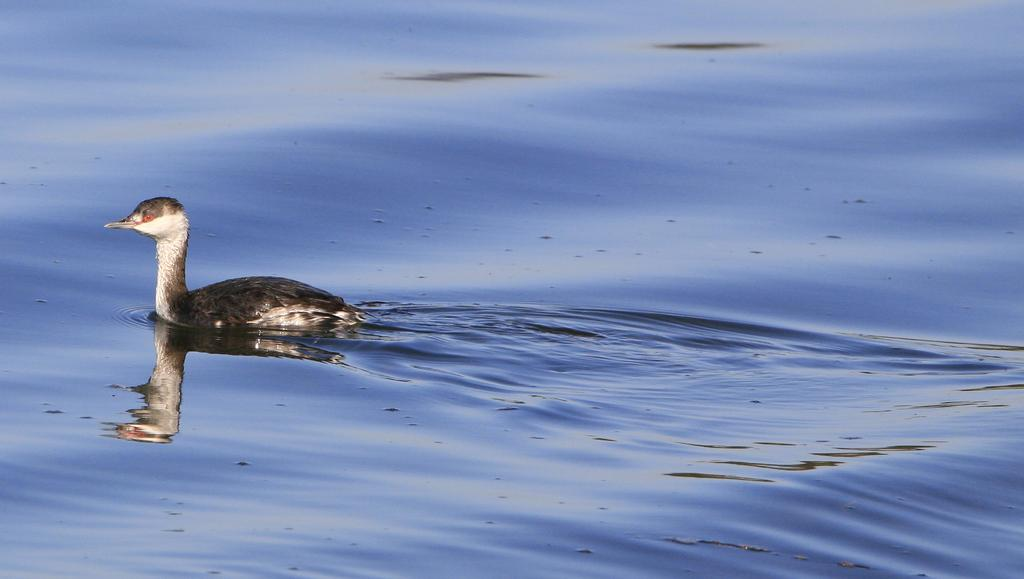What type of animal is present in the image? There is a duck in the image. Where is the duck located in the image? The duck is on the surface of water. Is there a boy sitting on the duck in the image? No, there is no boy sitting on the duck in the image. Can you see any wounds on the duck in the image? No, there are no wounds visible on the duck in the image. 